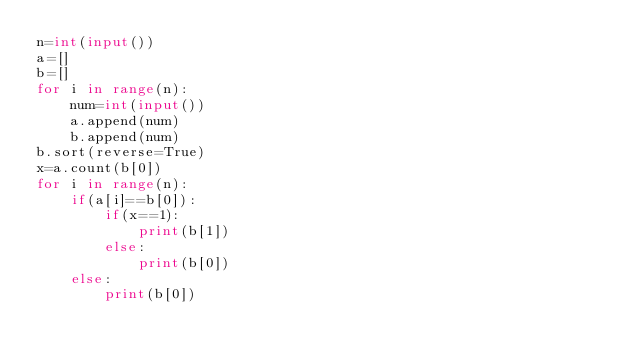Convert code to text. <code><loc_0><loc_0><loc_500><loc_500><_Python_>n=int(input())
a=[]
b=[]
for i in range(n):
    num=int(input())
    a.append(num)
    b.append(num)
b.sort(reverse=True)
x=a.count(b[0])
for i in range(n):
    if(a[i]==b[0]):
        if(x==1):
            print(b[1])
        else:
            print(b[0])
    else:
        print(b[0])
</code> 